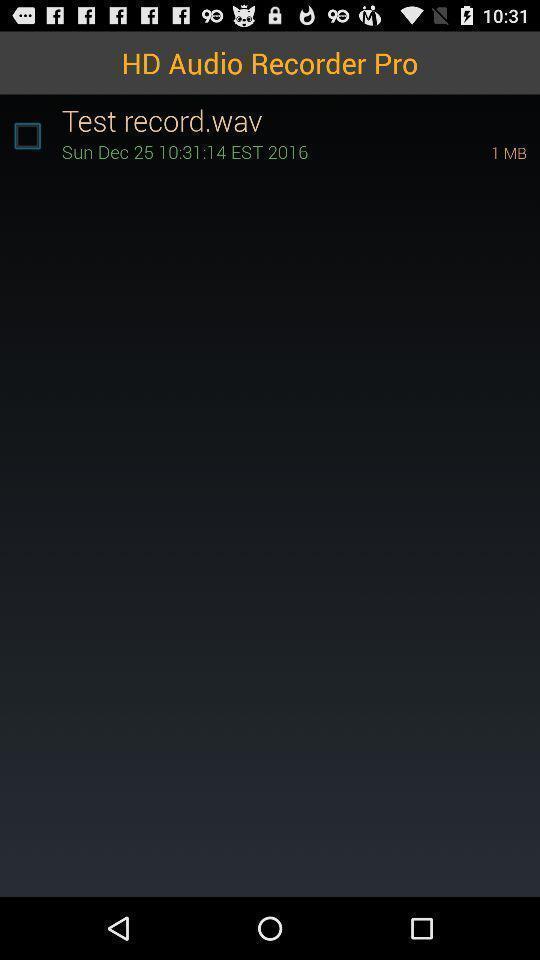Describe the key features of this screenshot. Screen page of a audio recorder. 